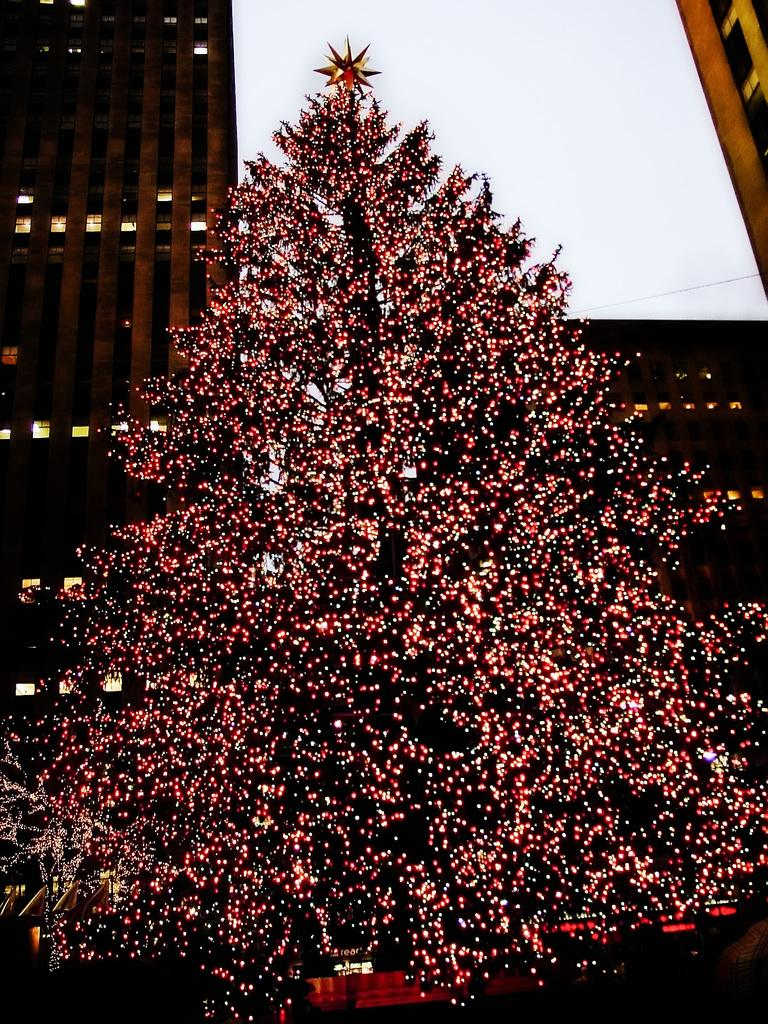What is the main feature of the tree in the image? The tree in the image has lights on it. Are there any decorations on the tree? Yes, there is a star on the tree. What can be seen in the background of the image? There is a posture and a building visible in the background. What type of wound can be seen on the tree in the image? There is no wound visible on the tree in the image; it is decorated with lights and a star. 